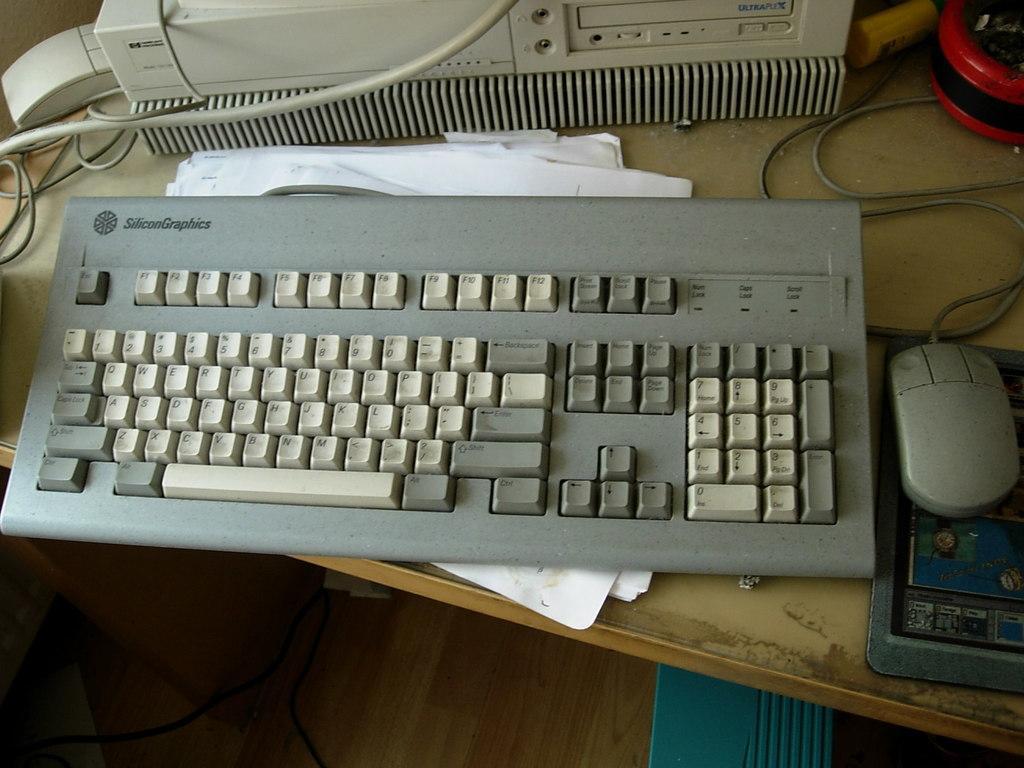Could you give a brief overview of what you see in this image? In this image I can see a key board,mouse papers and also a machine with wires and also a red color object on the table. And down there is a blue color object can be seen. 